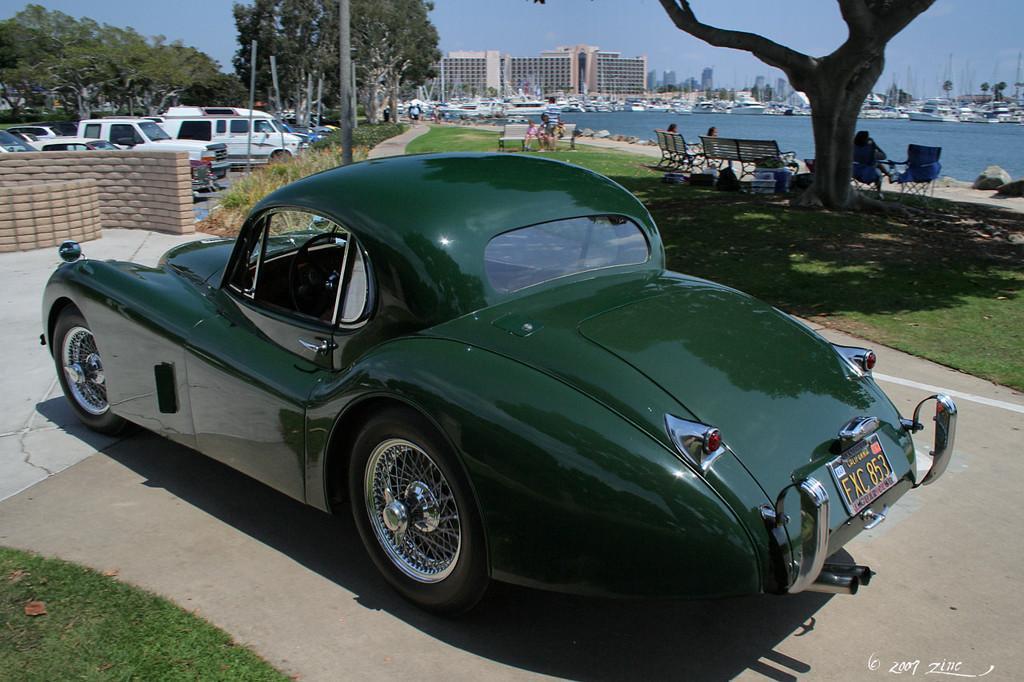Please provide a concise description of this image. In the foreground I can see grass, fleets of cars on the road, fence, benches, trees, chairs, group of people, water, poles and plants. In the background I can see fleets of boats in the water, buildings, towers, light poles and the sky. This image is taken may be during a day. 